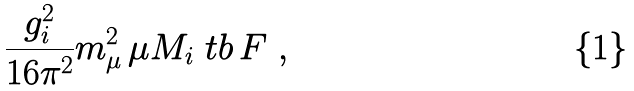Convert formula to latex. <formula><loc_0><loc_0><loc_500><loc_500>\frac { g _ { i } ^ { 2 } } { 1 6 \pi ^ { 2 } } m _ { \mu } ^ { 2 } \, \mu M _ { i } \ t b \, F \ ,</formula> 